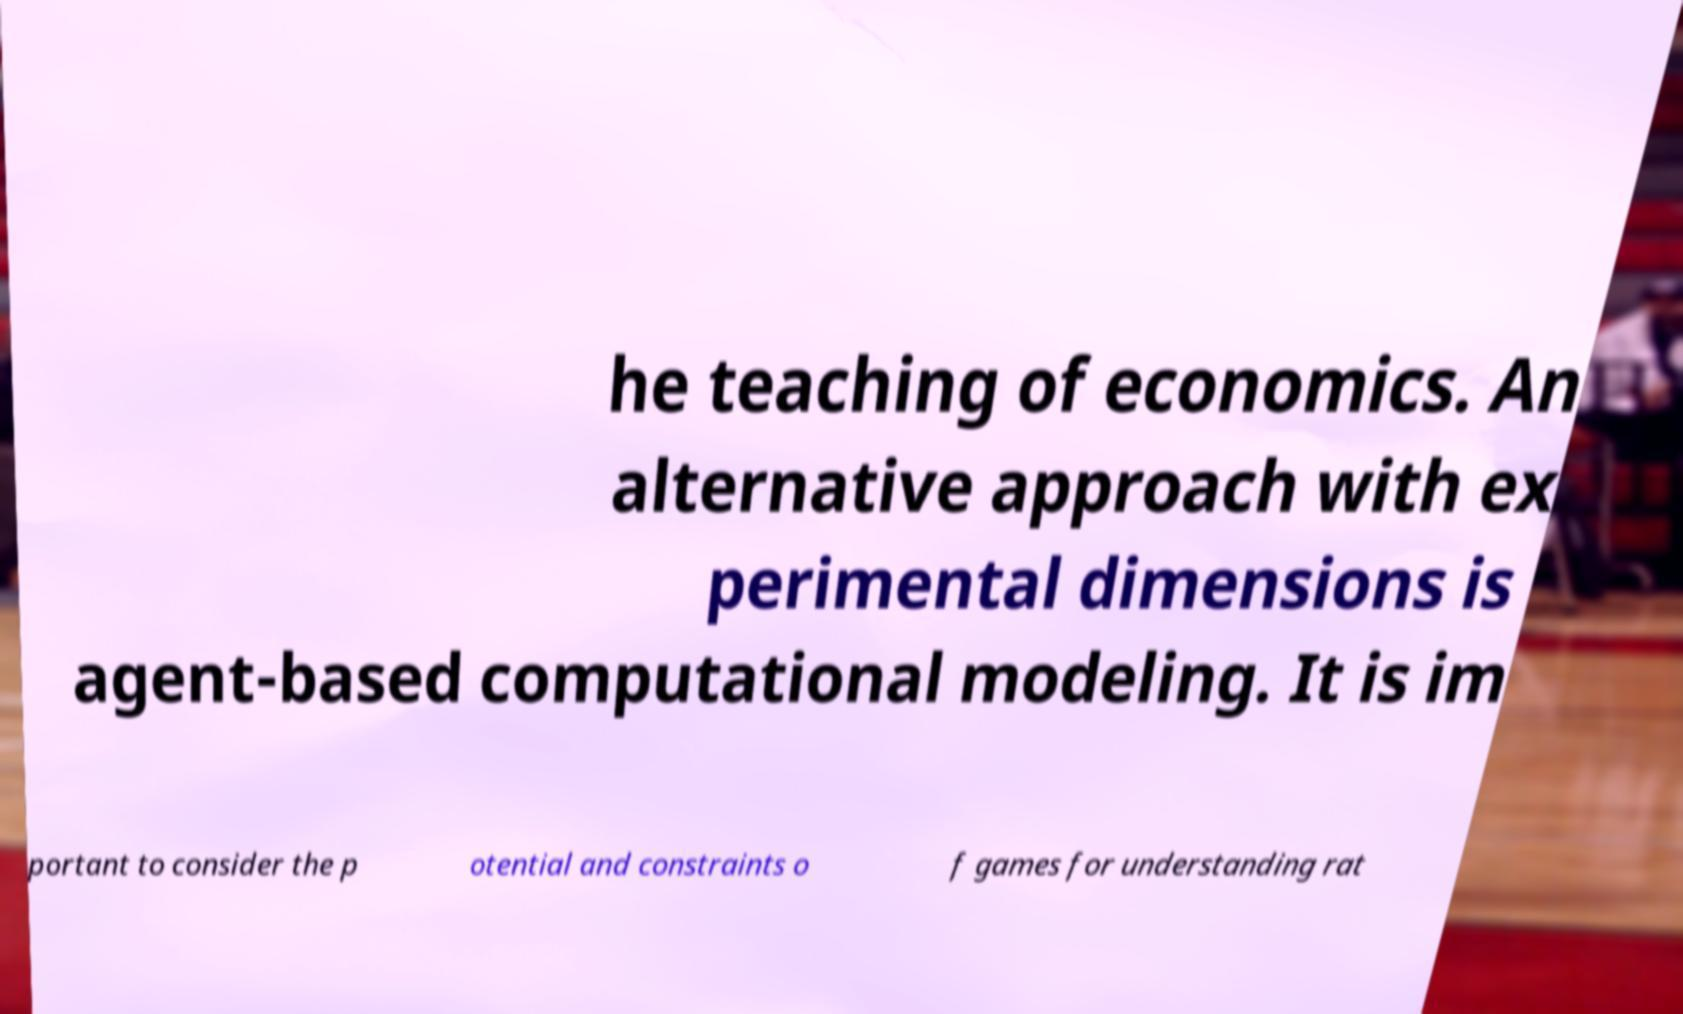For documentation purposes, I need the text within this image transcribed. Could you provide that? he teaching of economics. An alternative approach with ex perimental dimensions is agent-based computational modeling. It is im portant to consider the p otential and constraints o f games for understanding rat 